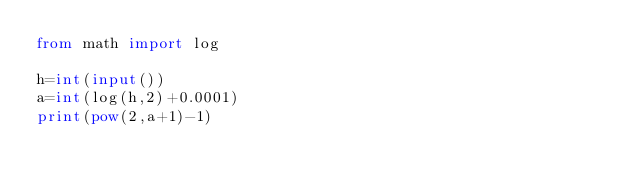Convert code to text. <code><loc_0><loc_0><loc_500><loc_500><_Python_>from math import log

h=int(input())
a=int(log(h,2)+0.0001)
print(pow(2,a+1)-1)</code> 